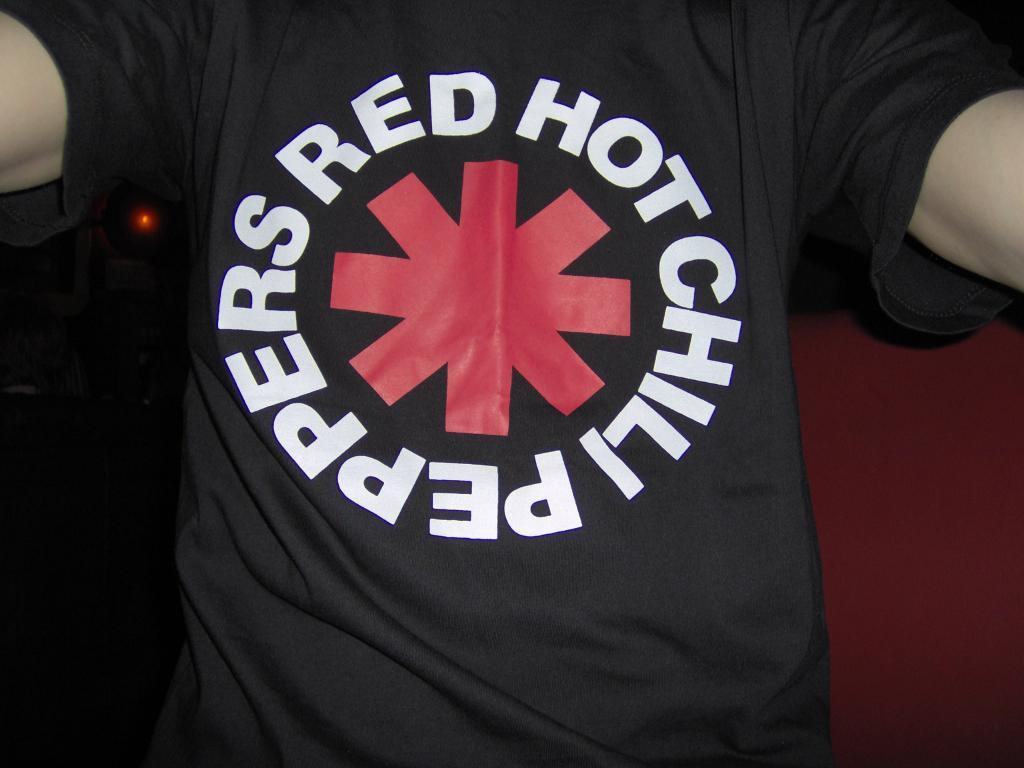<image>
Present a compact description of the photo's key features. A man wearing a black Red Got Chili Peppers shirt. 